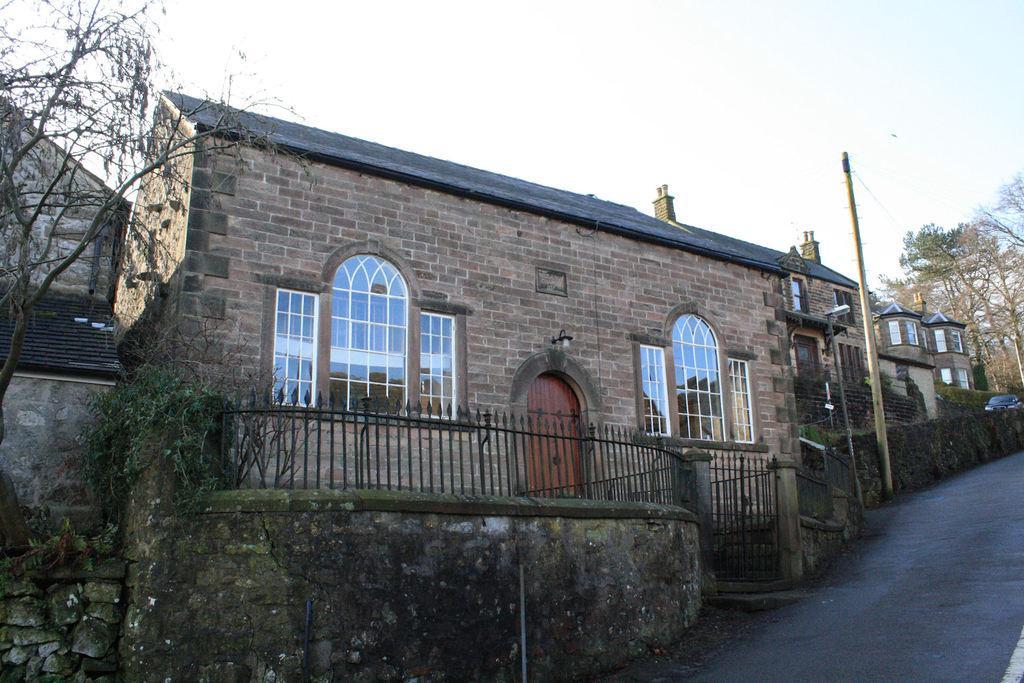Please provide a concise description of this image. In the center of the image there is a house. There is a road. There are trees. There is a electric pole. There is a fencing with wall. 